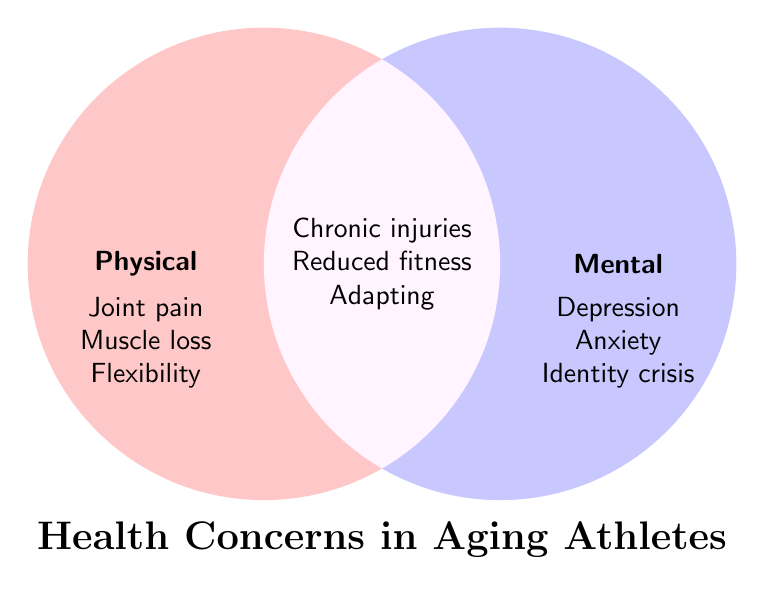what is the title of the figure? The title is the text placed at the bottom of the Venn Diagram which labels the overall concept being represented.
Answer: Health Concerns in Aging Athletes what are the categories shown in the Venn Diagram? The categories are labeled above the circles and represent different types of concerns in aging athletes.
Answer: Physical, Mental, Both Which concerns fall exclusively under Physical health? The concerns listed under the "Physical" category, observed on the left side of the diagram.
Answer: Joint pain, Muscle loss, Decreased flexibility Which concerns are categorized under Mental health? The concerns specified in the "Mental" section on the right circle of the diagram.
Answer: Depression, Anxiety, Identity crisis What are the shared concerns between Physical and Mental health? The concerns listed in the overlapping section of both circles, indicating they pertain to both Physical and Mental health.
Answer: Chronic injuries, Reduced overall fitness, Difficulty adapting to new routines How many total concerns are listed in the figure? Add the concerns from all three categories: physical (3), mental (3), and both (3).
Answer: 9 Are there more Physical health concerns or Mental health concerns? Compare the number of concerns in the Physical category versus the Mental category by counting them.
Answer: They are equal Which concern categories contain "Reduced overall fitness"? Check the overlapping section that "Reduced overall fitness" falls into on the diagram, indicating both types.
Answer: Both Are Chronic injuries considered a Physical or a Mental health concern? Examine the concern under the Venn Diagram overlapping section that indicates it pertains to both categories.
Answer: Both 